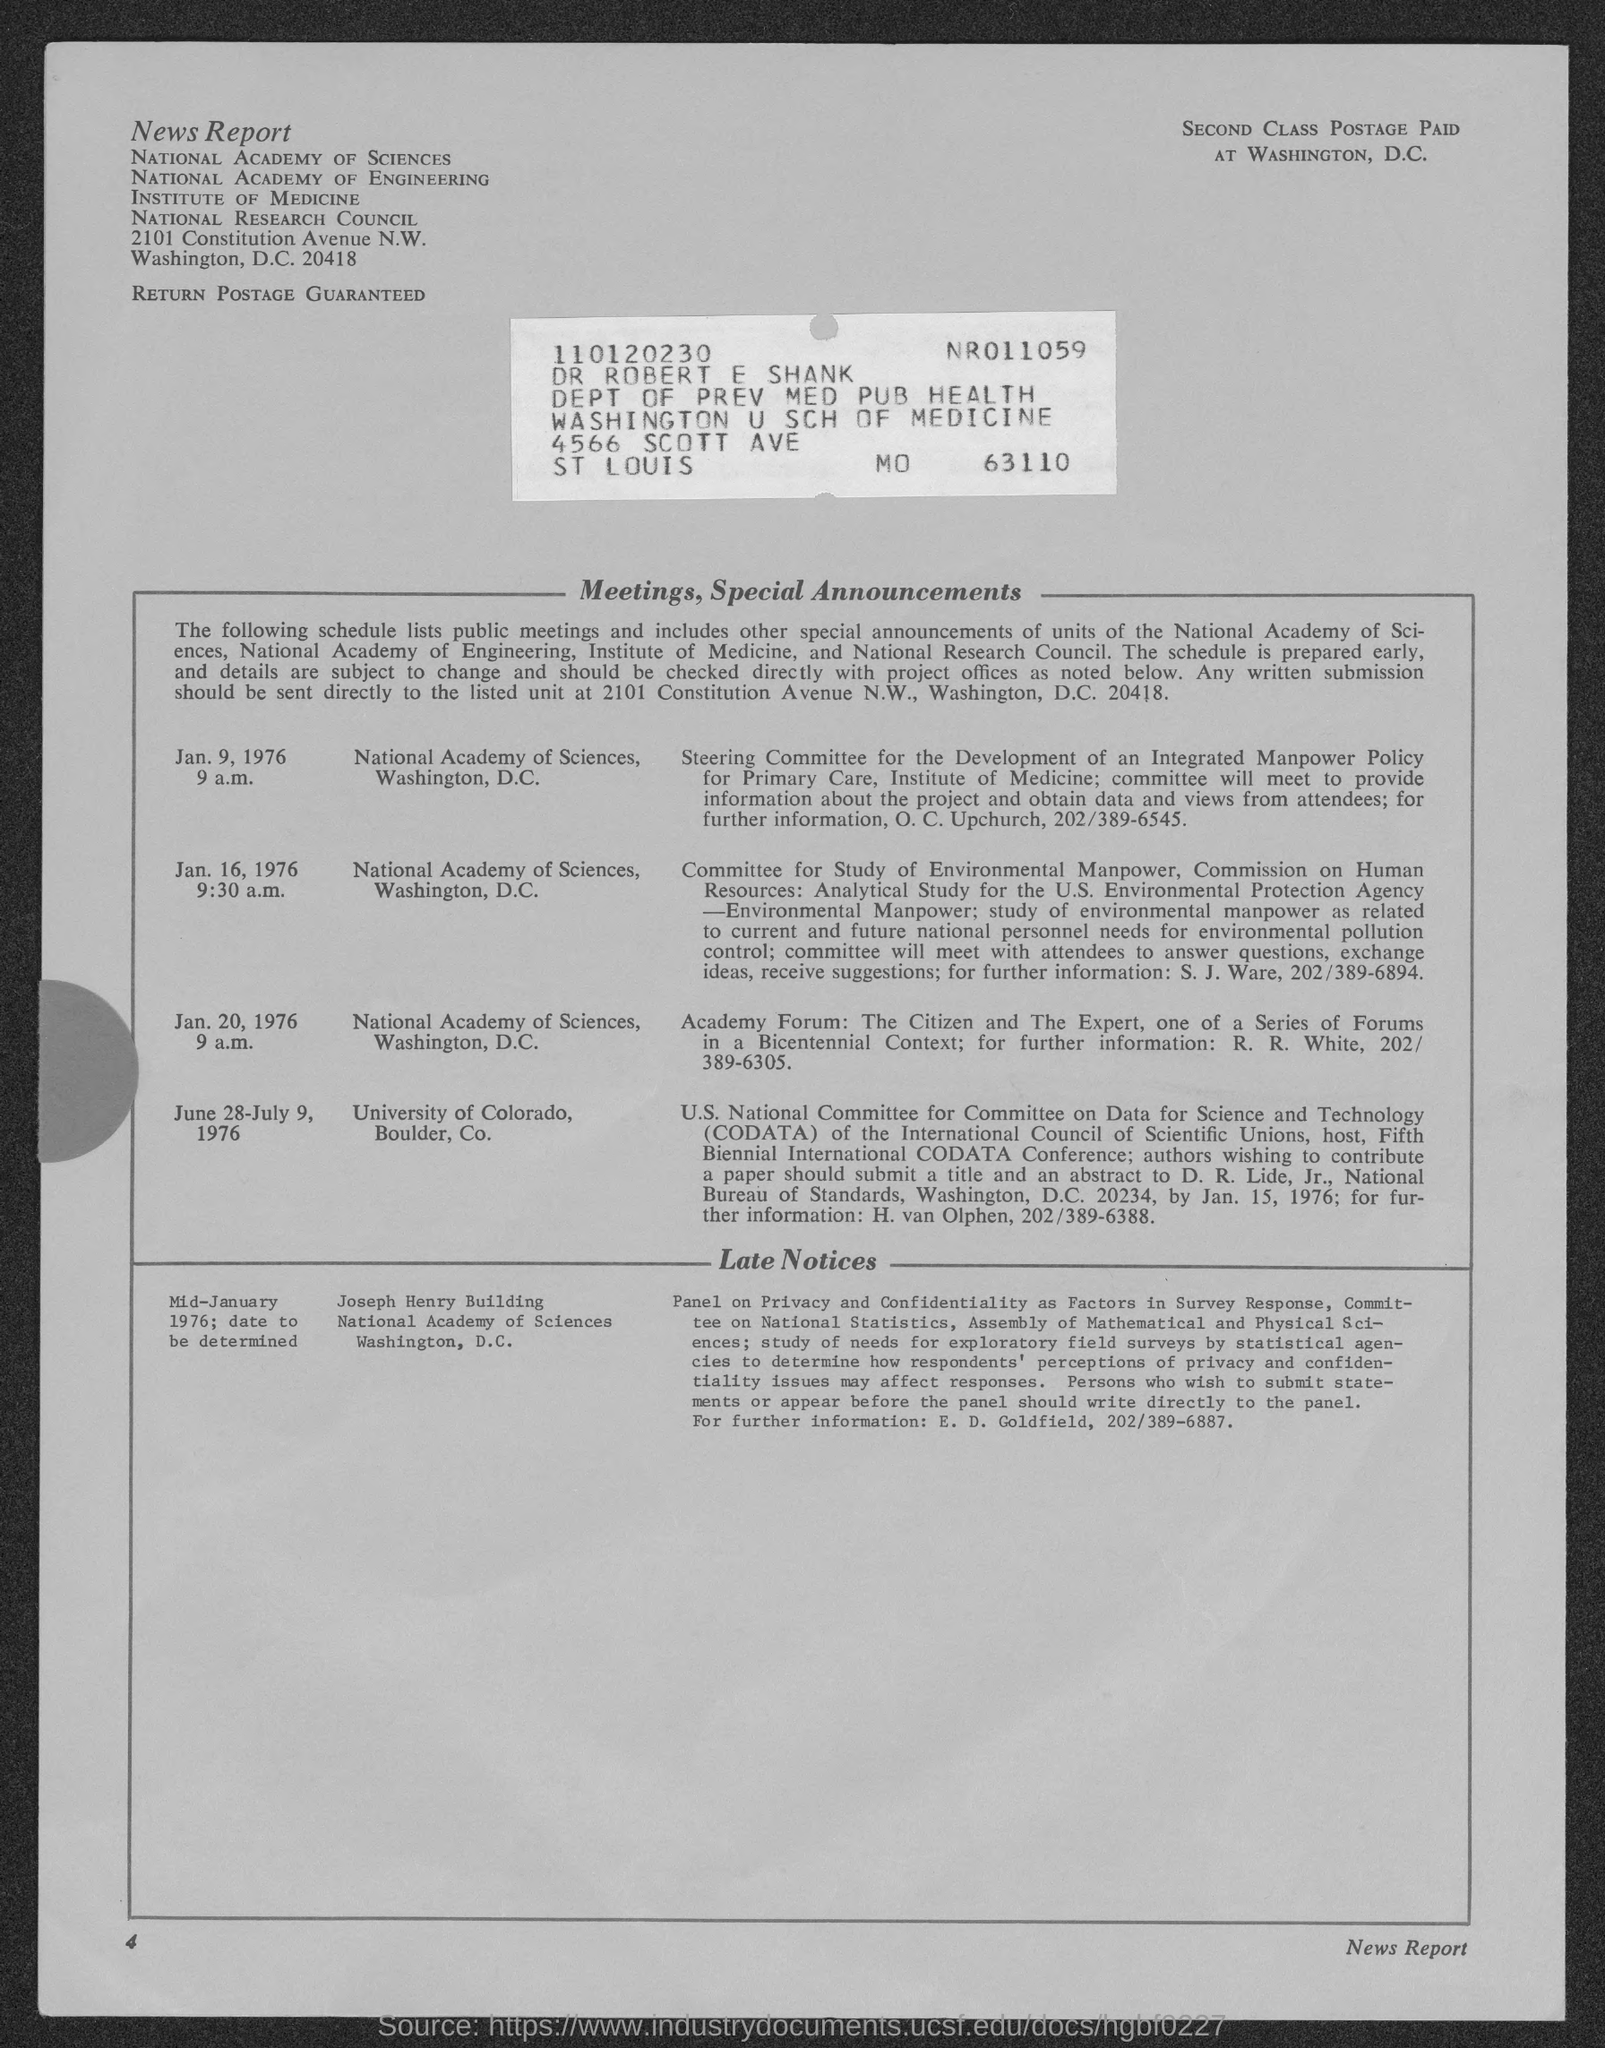What kind of "Report" is this?
Your answer should be very brief. News Report. Which "DEPT" does "Dr ROBERT E SHANK" belong to?
Ensure brevity in your answer.  DEPT OF PREV MED PUB HEALTH. What is the page number given at left bottom corner of the page?
Your answer should be compact. 4. What is the abbreviation for U.S National Committee on Data for Science and Technology"?
Keep it short and to the point. CODATA. "SECOND CLASS POSTAGE PAID" at which place is mentioned?
Provide a short and direct response. WASHINGTON, D.C. What time is meeting on Jan. 9,1976?
Give a very brief answer. 9 a.m. What time is meeting on Jan. 16,1976?
Offer a terse response. 9:30 a.m. What time is meeting on Jan. 20,1976?
Offer a very short reply. 9 a.m. 